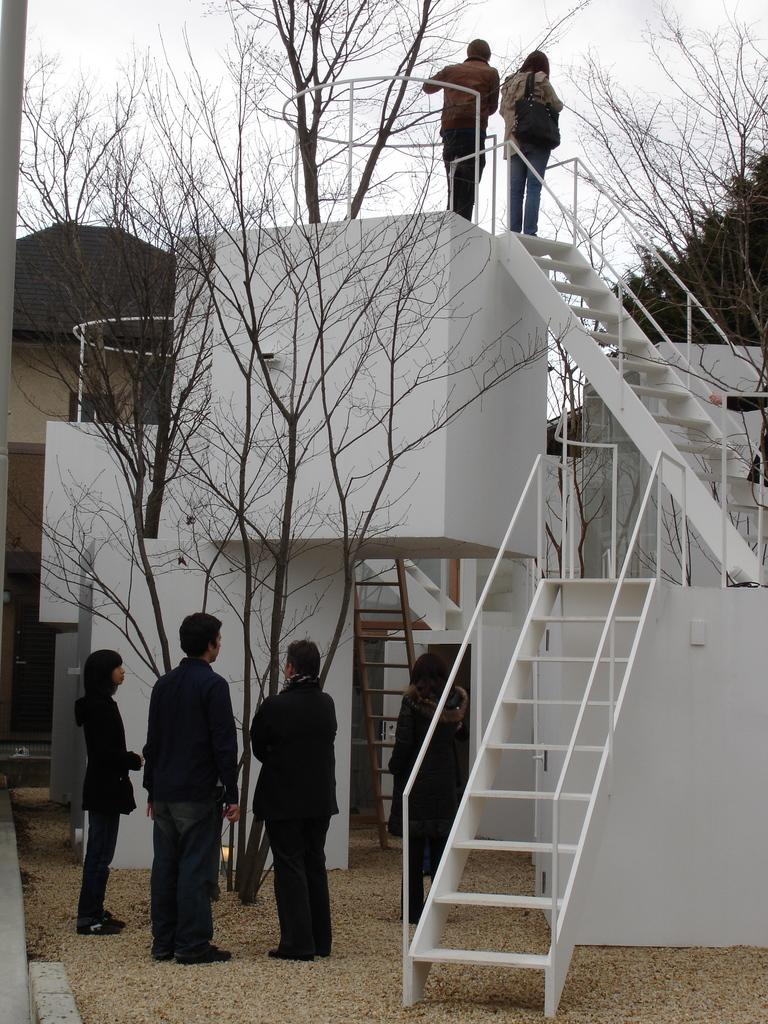What type of structure can be seen in the image? There is a house in the image. What can be found near the house? There are stairs and dried trees in the image. Are there any people present in the image? Yes, there are people standing in the image. What is visible in the background of the image? The sky is visible in the background of the image. What type of meat is being served at the health clinic in the image? There is no health clinic or meat present in the image. 